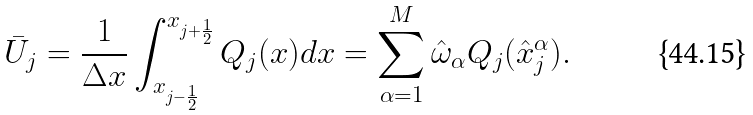<formula> <loc_0><loc_0><loc_500><loc_500>\bar { U } _ { j } = \frac { 1 } { \Delta x } \int _ { x _ { j - \frac { 1 } { 2 } } } ^ { x _ { j + \frac { 1 } { 2 } } } Q _ { j } ( x ) d x = \sum _ { \alpha = 1 } ^ { M } \hat { \omega } _ { \alpha } Q _ { j } ( \hat { x } _ { j } ^ { \alpha } ) .</formula> 